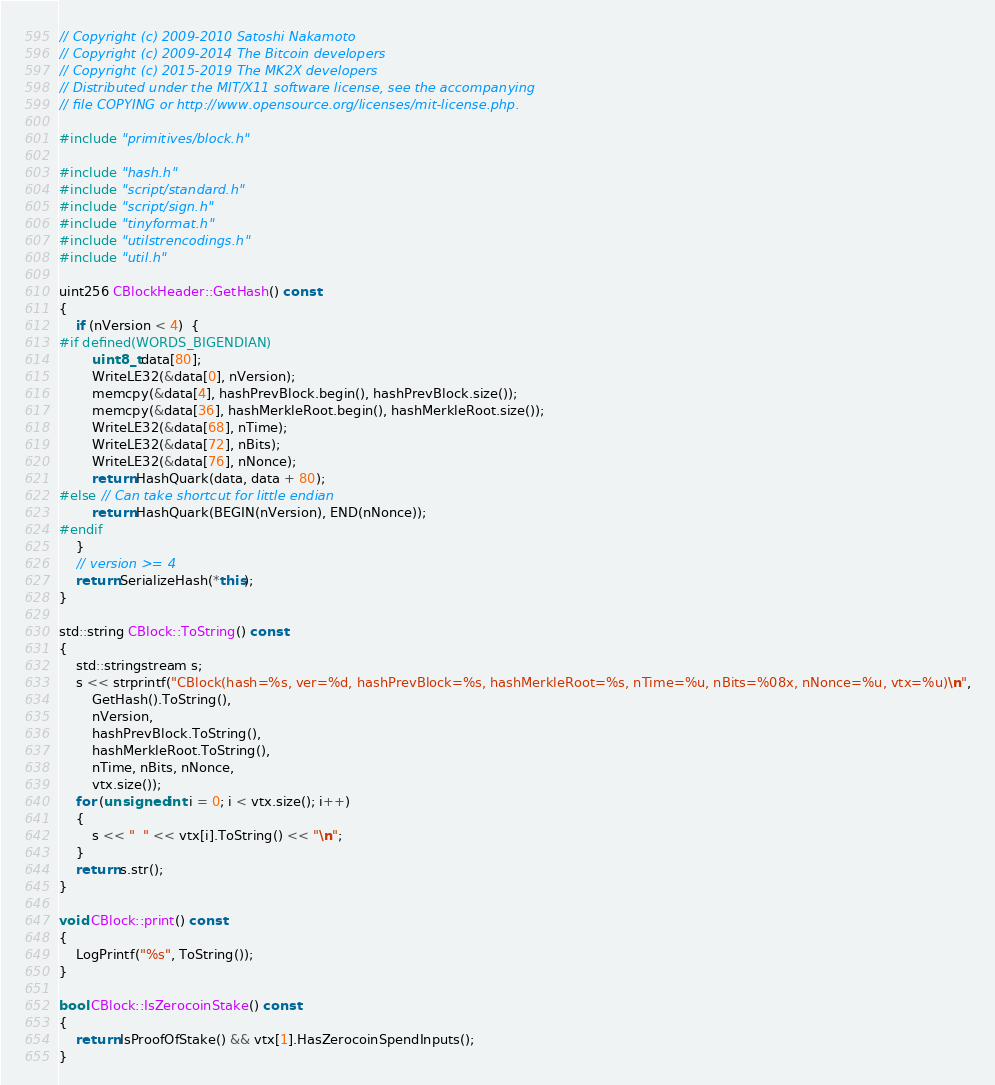<code> <loc_0><loc_0><loc_500><loc_500><_C++_>// Copyright (c) 2009-2010 Satoshi Nakamoto
// Copyright (c) 2009-2014 The Bitcoin developers
// Copyright (c) 2015-2019 The MK2X developers
// Distributed under the MIT/X11 software license, see the accompanying
// file COPYING or http://www.opensource.org/licenses/mit-license.php.

#include "primitives/block.h"

#include "hash.h"
#include "script/standard.h"
#include "script/sign.h"
#include "tinyformat.h"
#include "utilstrencodings.h"
#include "util.h"

uint256 CBlockHeader::GetHash() const
{
    if (nVersion < 4)  {
#if defined(WORDS_BIGENDIAN)
        uint8_t data[80];
        WriteLE32(&data[0], nVersion);
        memcpy(&data[4], hashPrevBlock.begin(), hashPrevBlock.size());
        memcpy(&data[36], hashMerkleRoot.begin(), hashMerkleRoot.size());
        WriteLE32(&data[68], nTime);
        WriteLE32(&data[72], nBits);
        WriteLE32(&data[76], nNonce);
        return HashQuark(data, data + 80);
#else // Can take shortcut for little endian
        return HashQuark(BEGIN(nVersion), END(nNonce));
#endif
    }
    // version >= 4
    return SerializeHash(*this);
}

std::string CBlock::ToString() const
{
    std::stringstream s;
    s << strprintf("CBlock(hash=%s, ver=%d, hashPrevBlock=%s, hashMerkleRoot=%s, nTime=%u, nBits=%08x, nNonce=%u, vtx=%u)\n",
        GetHash().ToString(),
        nVersion,
        hashPrevBlock.ToString(),
        hashMerkleRoot.ToString(),
        nTime, nBits, nNonce,
        vtx.size());
    for (unsigned int i = 0; i < vtx.size(); i++)
    {
        s << "  " << vtx[i].ToString() << "\n";
    }
    return s.str();
}

void CBlock::print() const
{
    LogPrintf("%s", ToString());
}

bool CBlock::IsZerocoinStake() const
{
    return IsProofOfStake() && vtx[1].HasZerocoinSpendInputs();
}
</code> 